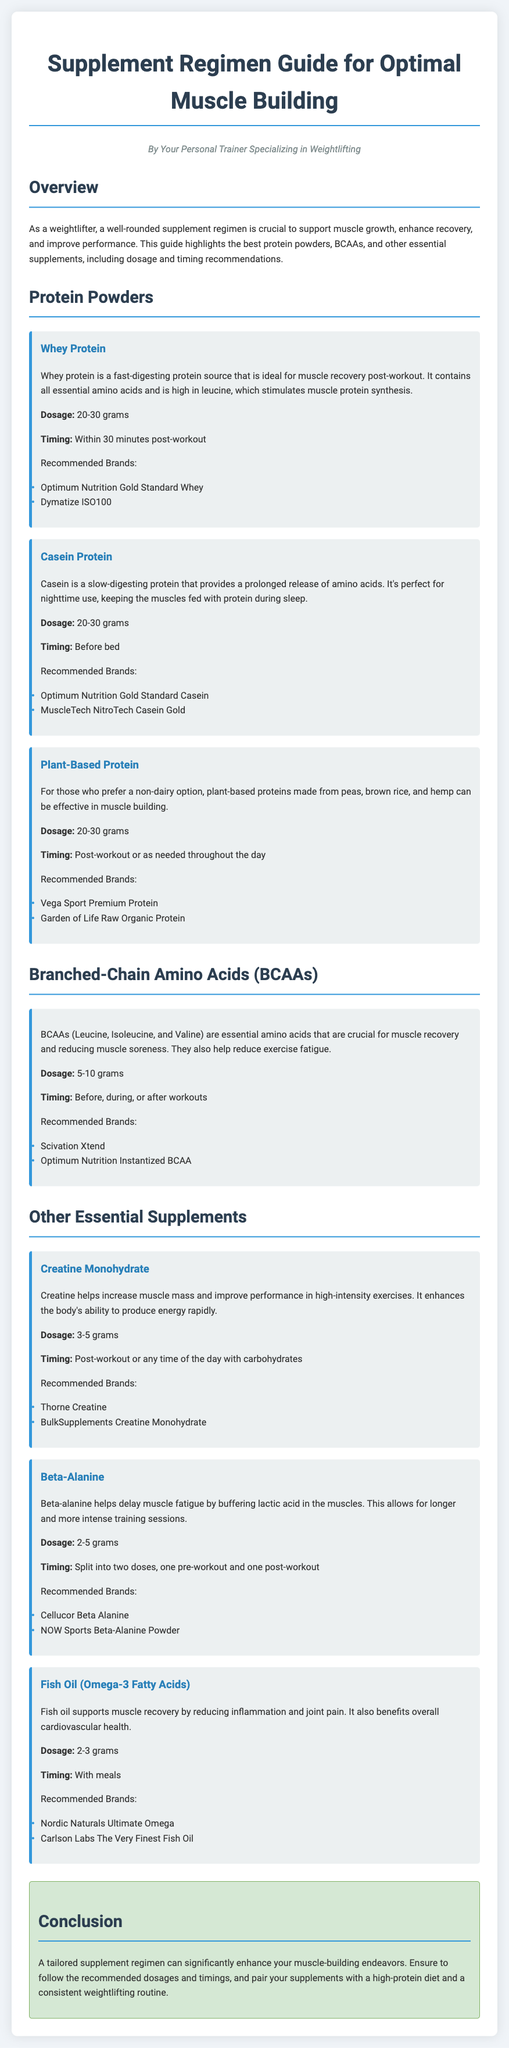What is the recommended dosage of Whey Protein? The recommended dosage for Whey Protein is indicated in the document as 20-30 grams.
Answer: 20-30 grams What is the timing for Casein Protein? The document specifies that Casein Protein should be taken before bed for optimal effects.
Answer: Before bed Which amino acids make up BCAAs? The document lists Leucine, Isoleucine, and Valine as the components of BCAAs.
Answer: Leucine, Isoleucine, Valine What is the purpose of Creatine according to the guide? The guide mentions that Creatine helps increase muscle mass and improve performance in high-intensity exercises.
Answer: Increase muscle mass and improve performance Which brand is recommended for Beta-Alanine? The document recommends Cellucor Beta Alanine as a brand for Beta-Alanine supplementation.
Answer: Cellucor Beta Alanine What is the significance of Fish Oil in muscle recovery? The document explains that Fish Oil supports muscle recovery by reducing inflammation and joint pain.
Answer: Reducing inflammation and joint pain What is the timing for taking BCAAs? The document states that BCAAs can be taken before, during, or after workouts.
Answer: Before, during, or after workouts Name one plant-based protein option mentioned in the guide. The guide mentions Vega Sport Premium Protein as a plant-based protein option.
Answer: Vega Sport Premium Protein 